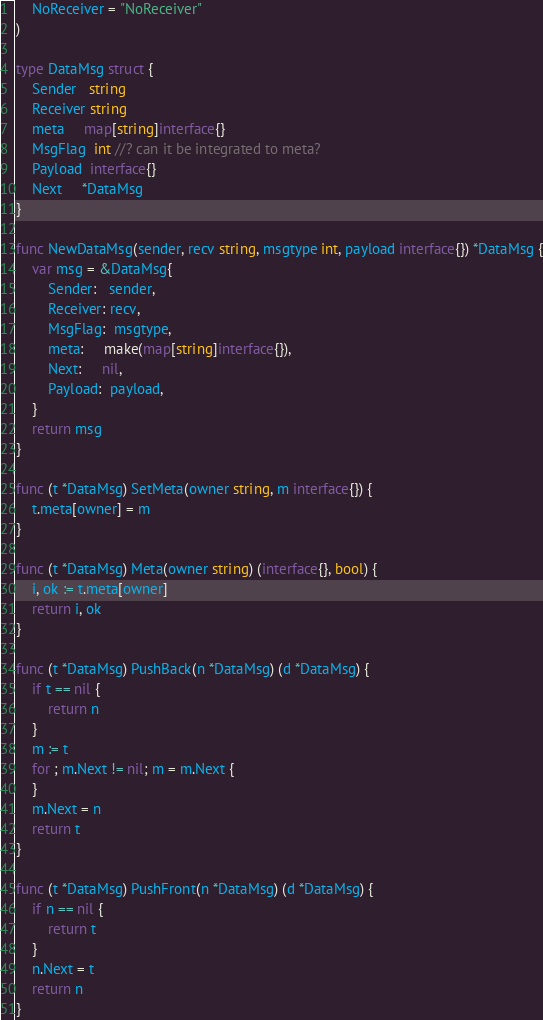Convert code to text. <code><loc_0><loc_0><loc_500><loc_500><_Go_>	NoReceiver = "NoReceiver"
)

type DataMsg struct {
	Sender   string
	Receiver string
	meta     map[string]interface{}
	MsgFlag  int //? can it be integrated to meta?
	Payload  interface{}
	Next     *DataMsg
}

func NewDataMsg(sender, recv string, msgtype int, payload interface{}) *DataMsg {
	var msg = &DataMsg{
		Sender:   sender,
		Receiver: recv,
		MsgFlag:  msgtype,
		meta:     make(map[string]interface{}),
		Next:     nil,
		Payload:  payload,
	}
	return msg
}

func (t *DataMsg) SetMeta(owner string, m interface{}) {
	t.meta[owner] = m
}

func (t *DataMsg) Meta(owner string) (interface{}, bool) {
	i, ok := t.meta[owner]
	return i, ok
}

func (t *DataMsg) PushBack(n *DataMsg) (d *DataMsg) {
	if t == nil {
		return n
	}
	m := t
	for ; m.Next != nil; m = m.Next {
	}
	m.Next = n
	return t
}

func (t *DataMsg) PushFront(n *DataMsg) (d *DataMsg) {
	if n == nil {
		return t
	}
	n.Next = t
	return n
}
</code> 